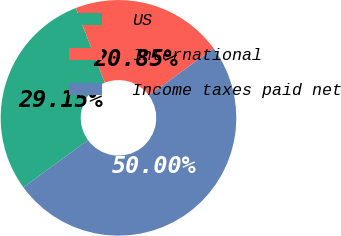<chart> <loc_0><loc_0><loc_500><loc_500><pie_chart><fcel>US<fcel>International<fcel>Income taxes paid net<nl><fcel>29.15%<fcel>20.85%<fcel>50.0%<nl></chart> 